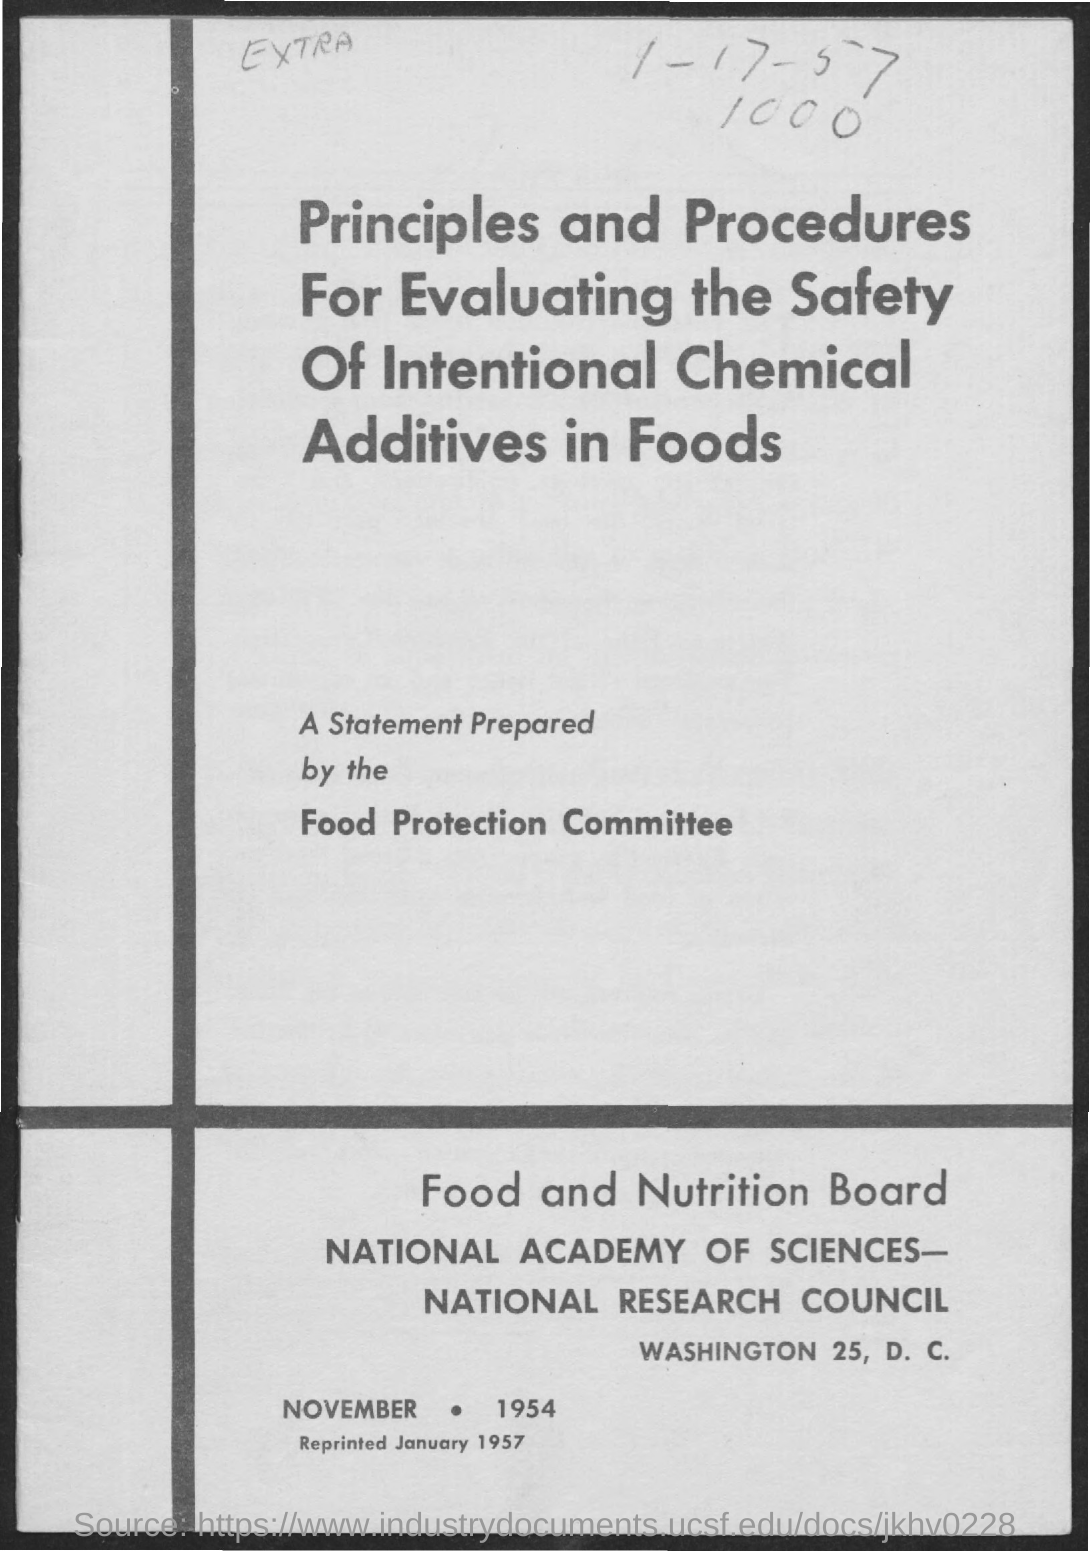Identify some key points in this picture. The place is Washington 25, D.C. 